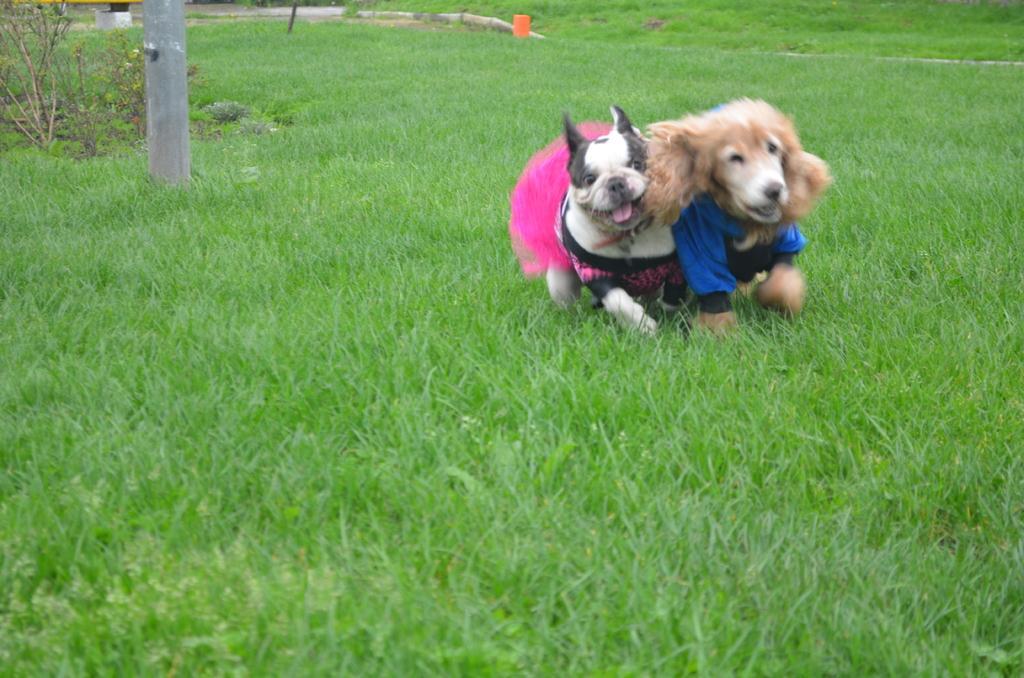Describe this image in one or two sentences. In this picture there are two dogs running on this ground. The dogs were in two different colors. One of the dogs is in white and black color and the other dog is in cream color. We can observe some grass on the ground. There is a pole in the left side. 